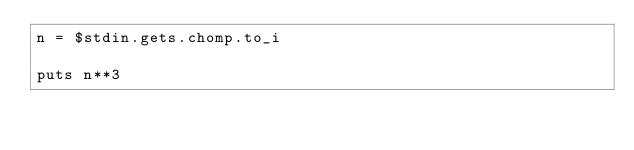<code> <loc_0><loc_0><loc_500><loc_500><_Ruby_>n = $stdin.gets.chomp.to_i

puts n**3</code> 